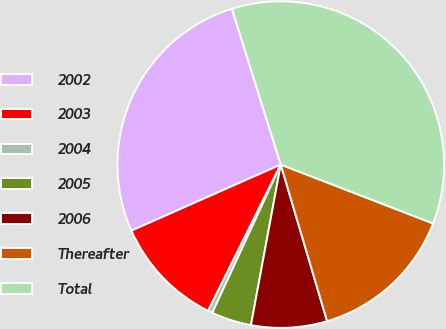<chart> <loc_0><loc_0><loc_500><loc_500><pie_chart><fcel>2002<fcel>2003<fcel>2004<fcel>2005<fcel>2006<fcel>Thereafter<fcel>Total<nl><fcel>26.8%<fcel>11.03%<fcel>0.45%<fcel>3.97%<fcel>7.5%<fcel>14.55%<fcel>35.71%<nl></chart> 